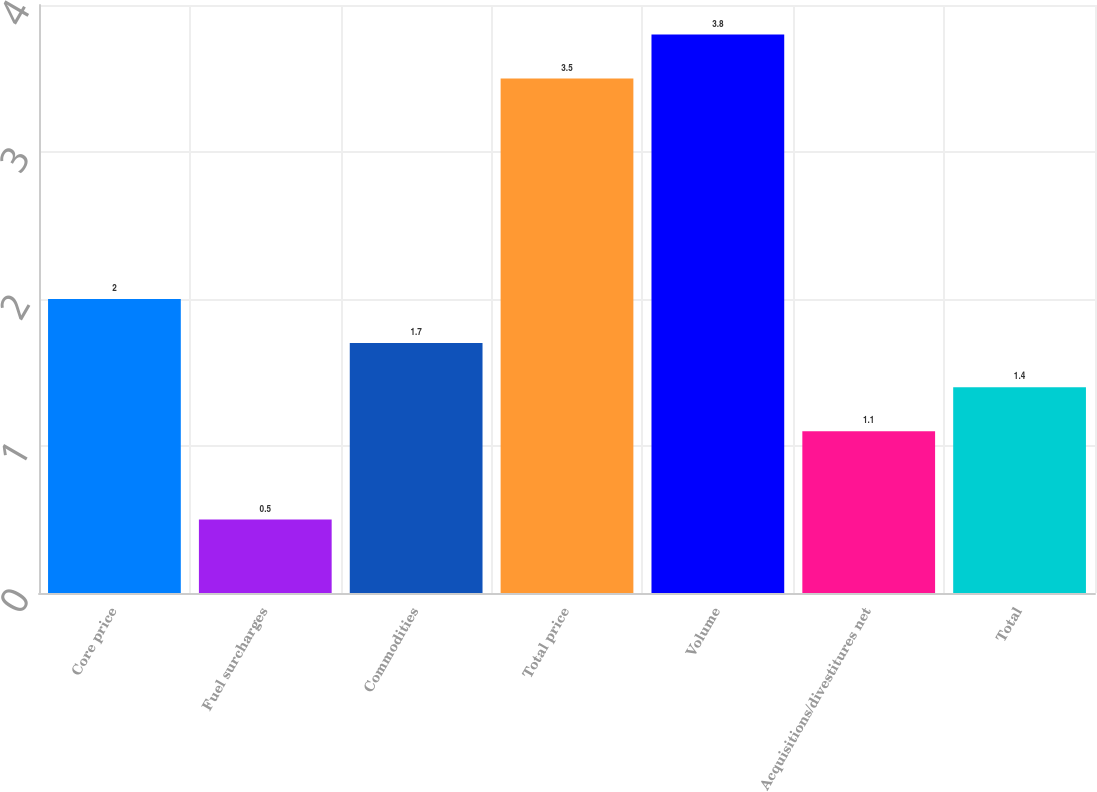Convert chart. <chart><loc_0><loc_0><loc_500><loc_500><bar_chart><fcel>Core price<fcel>Fuel surcharges<fcel>Commodities<fcel>Total price<fcel>Volume<fcel>Acquisitions/divestitures net<fcel>Total<nl><fcel>2<fcel>0.5<fcel>1.7<fcel>3.5<fcel>3.8<fcel>1.1<fcel>1.4<nl></chart> 